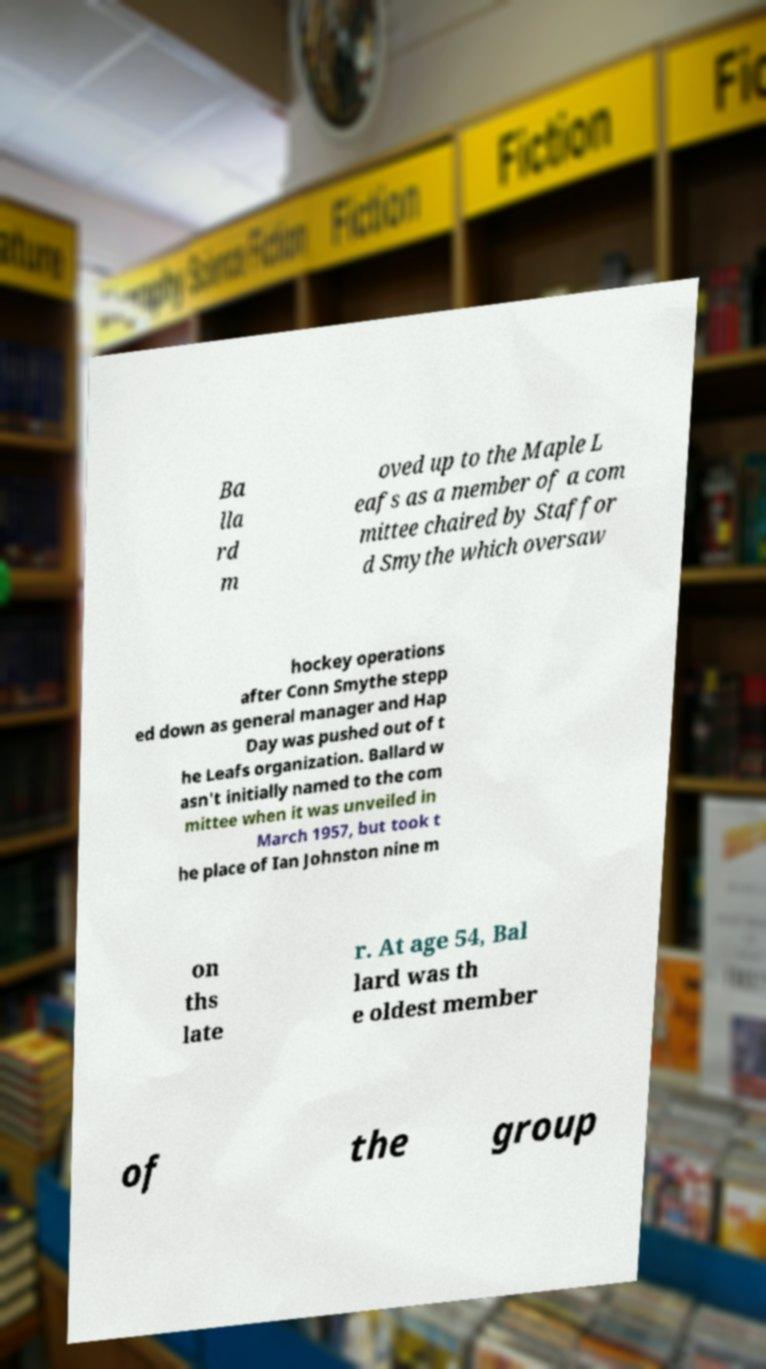Could you assist in decoding the text presented in this image and type it out clearly? Ba lla rd m oved up to the Maple L eafs as a member of a com mittee chaired by Staffor d Smythe which oversaw hockey operations after Conn Smythe stepp ed down as general manager and Hap Day was pushed out of t he Leafs organization. Ballard w asn't initially named to the com mittee when it was unveiled in March 1957, but took t he place of Ian Johnston nine m on ths late r. At age 54, Bal lard was th e oldest member of the group 